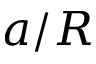Convert formula to latex. <formula><loc_0><loc_0><loc_500><loc_500>a / R</formula> 